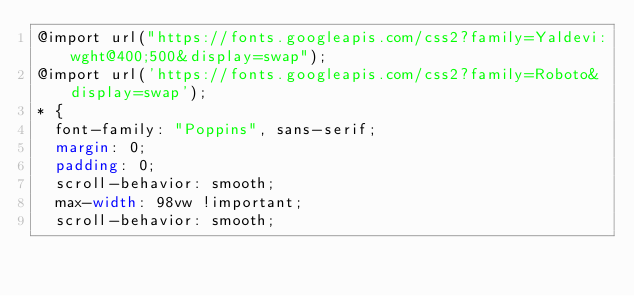<code> <loc_0><loc_0><loc_500><loc_500><_CSS_>@import url("https://fonts.googleapis.com/css2?family=Yaldevi:wght@400;500&display=swap");
@import url('https://fonts.googleapis.com/css2?family=Roboto&display=swap');
* {
  font-family: "Poppins", sans-serif;
  margin: 0;
  padding: 0;
  scroll-behavior: smooth;
  max-width: 98vw !important;
  scroll-behavior: smooth;</code> 